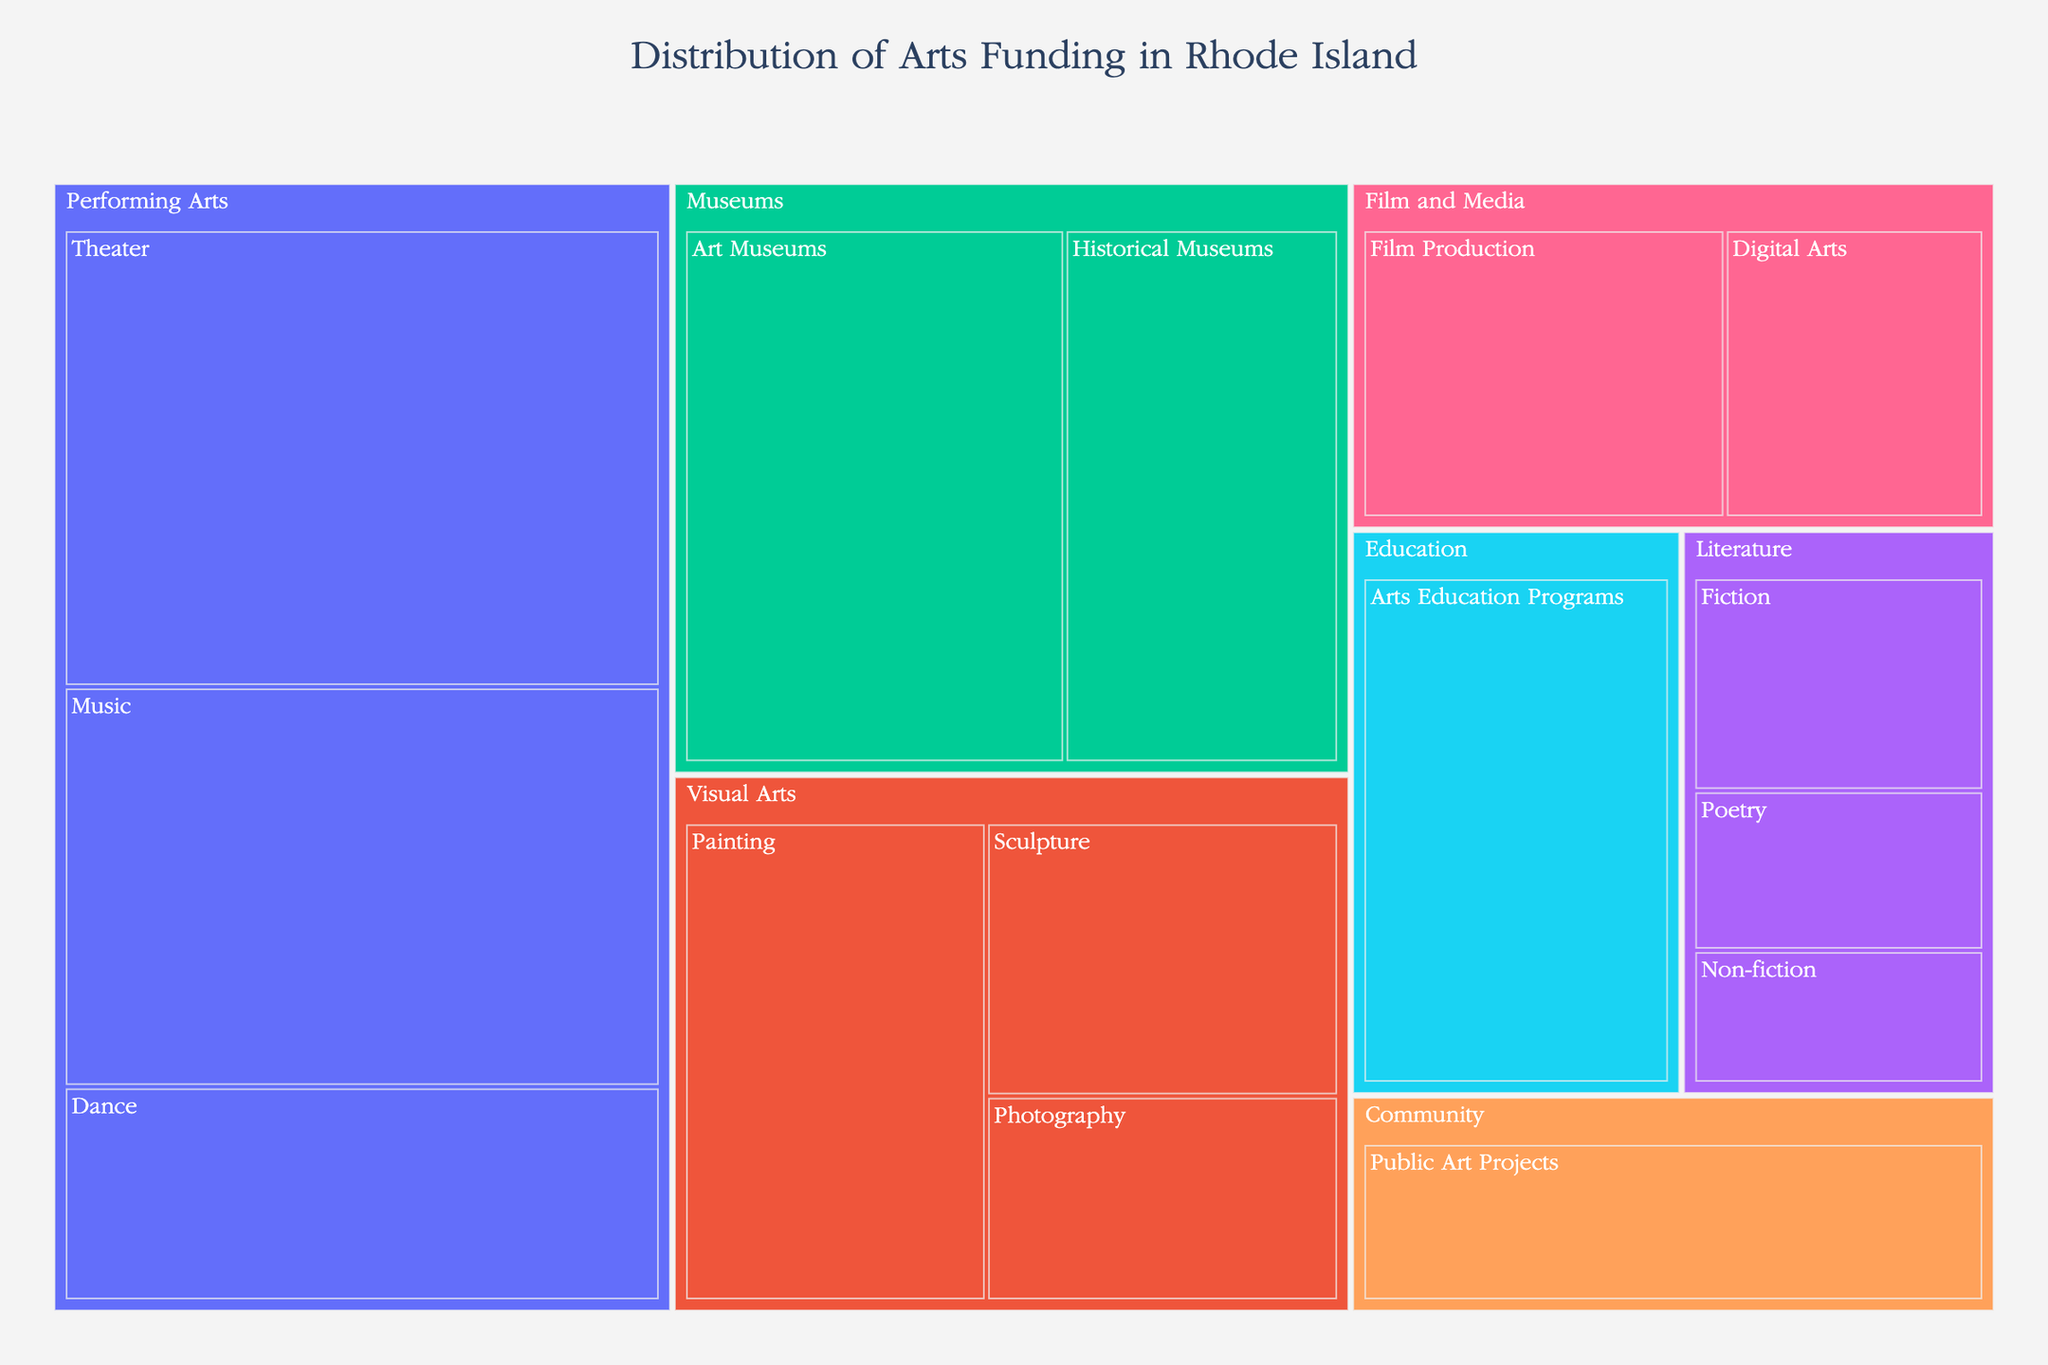What is the title of the treemap? The title of the treemap is usually located at the top of the figure and provides an overview of the data being visualized. In this case, we are looking for the main heading.
Answer: Distribution of Arts Funding in Rhode Island Which category received the highest funding? To determine which category received the highest funding, look at the labeled blocks in the treemap and compare their sizes and funding values.
Answer: Performing Arts How much funding was allocated to Visual Arts? To find the total funding for Visual Arts, locate the Visual Arts category in the treemap and sum the funding for its subcategories: Painting, Sculpture, and Photography.
Answer: $3,900,000 Which subcategory within Performing Arts has the lowest funding? Within the Performing Arts category, identify the subcategories (Theater, Music, Dance) and compare their funding values to find the smallest one.
Answer: Dance Compare the funding for Arts Education Programs and Public Art Projects. Which one received more funding? Locate Arts Education Programs under the Education category and Public Art Projects under the Community category in the treemap, then compare their funding values.
Answer: Arts Education Programs What is the combined funding for all Literature subcategories? Add the funding for Fiction, Poetry, and Non-fiction subcategories under the Literature category to get the total funding.
Answer: $1,900,000 Which Museum subcategory has more funding, Art Museums or Historical Museums? Locate both Art Museums and Historical Museums under the Museums category in the treemap and compare their funding values.
Answer: Art Museums What is the total funding for the Film and Media category? Sum the funding for Film Production and Digital Arts subcategories under the Film and Media category to obtain the total funding.
Answer: $2,400,000 What percentage of the total funding is allocated to the Theater subcategory? First, sum up all the funding amounts to find the total funding. Then, divide the funding for Theater by this total amount and multiply by 100 to get the percentage.
Answer: 16.5% Which categories have subcategories with exactly $1,000,000 funding? Look for subcategories with $1,000,000 funding in the treemap and identify their respective categories.
Answer: Film and Media 